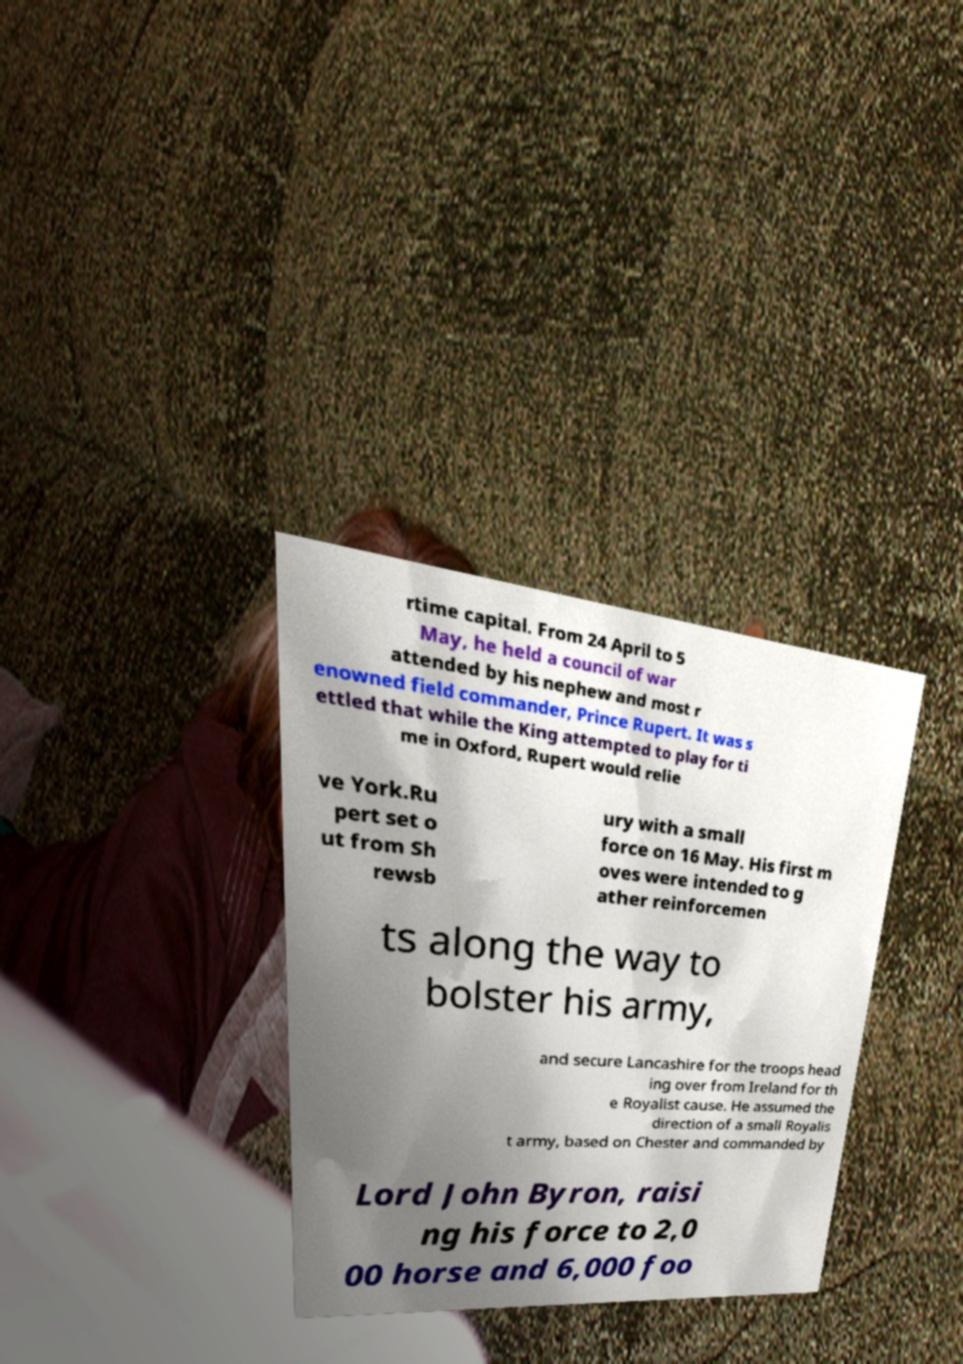For documentation purposes, I need the text within this image transcribed. Could you provide that? rtime capital. From 24 April to 5 May, he held a council of war attended by his nephew and most r enowned field commander, Prince Rupert. It was s ettled that while the King attempted to play for ti me in Oxford, Rupert would relie ve York.Ru pert set o ut from Sh rewsb ury with a small force on 16 May. His first m oves were intended to g ather reinforcemen ts along the way to bolster his army, and secure Lancashire for the troops head ing over from Ireland for th e Royalist cause. He assumed the direction of a small Royalis t army, based on Chester and commanded by Lord John Byron, raisi ng his force to 2,0 00 horse and 6,000 foo 